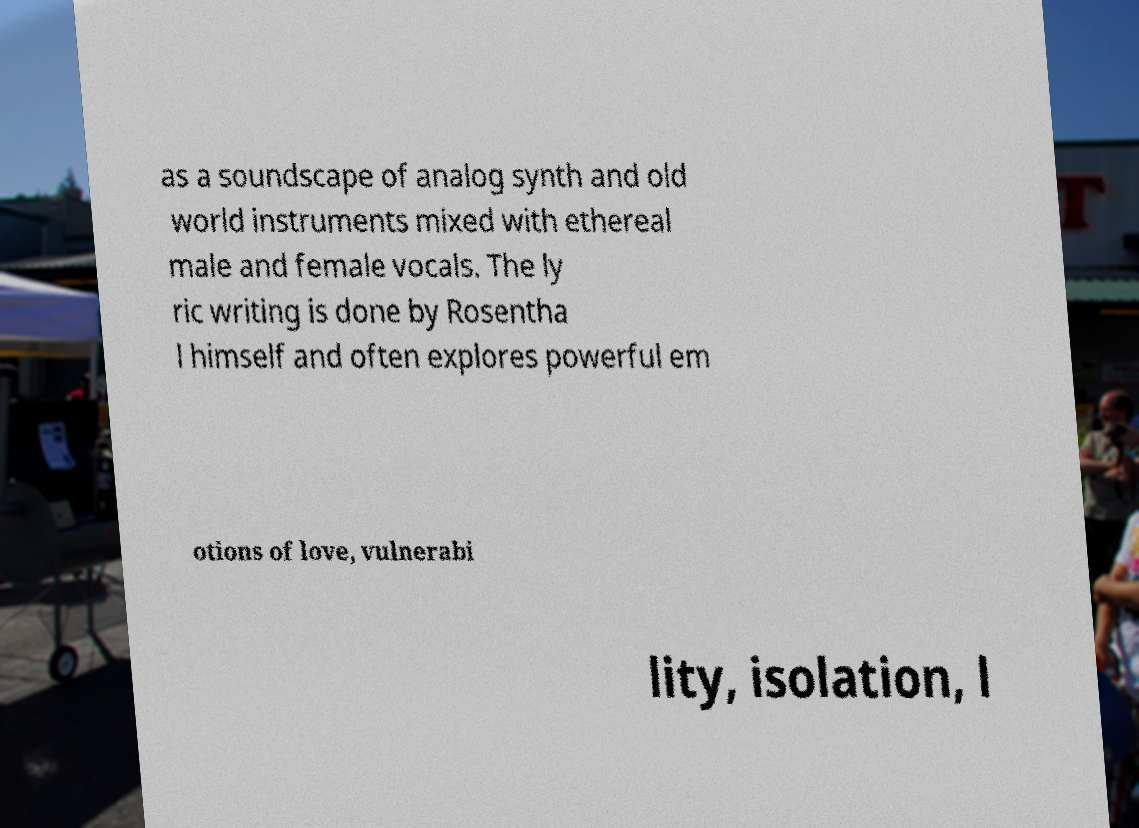Could you extract and type out the text from this image? as a soundscape of analog synth and old world instruments mixed with ethereal male and female vocals. The ly ric writing is done by Rosentha l himself and often explores powerful em otions of love, vulnerabi lity, isolation, l 